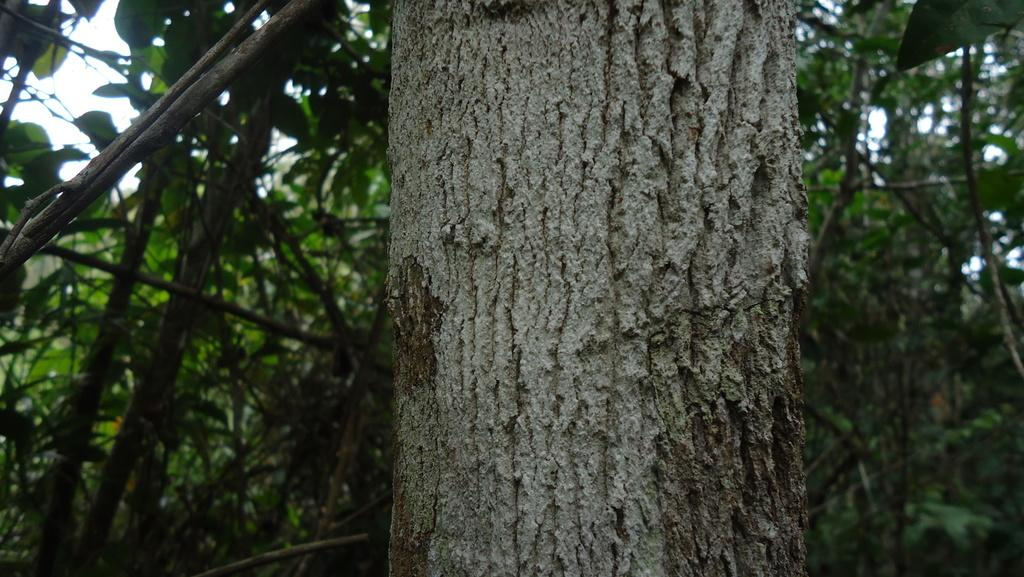What type of vegetation is in the middle of the image? There are there any trees? What can be seen at the top of the image? The sky is visible at the top of the image. Is there a river flowing through the trees in the image? There is no river visible in the image; it only features trees and the sky. What type of discovery was made in the image? There is no mention of a discovery in the image, as it only contains trees and the sky. 